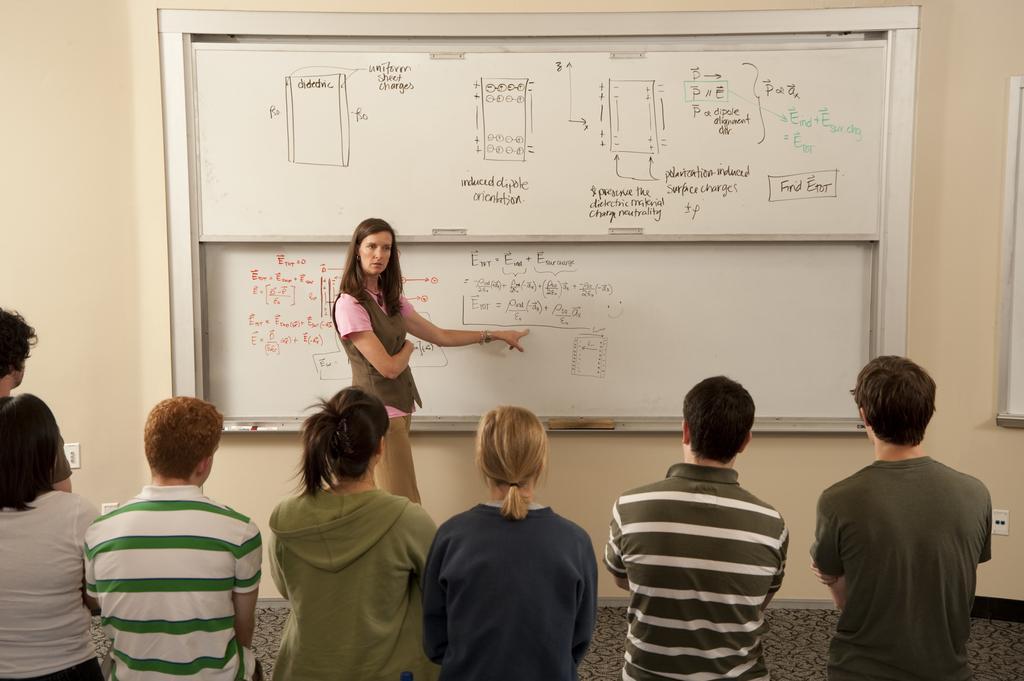Describe this image in one or two sentences. In the foreground, I can see a group of people are standing on the floor, in front of a white board and I can see a wall. This picture might be taken in a hall. 